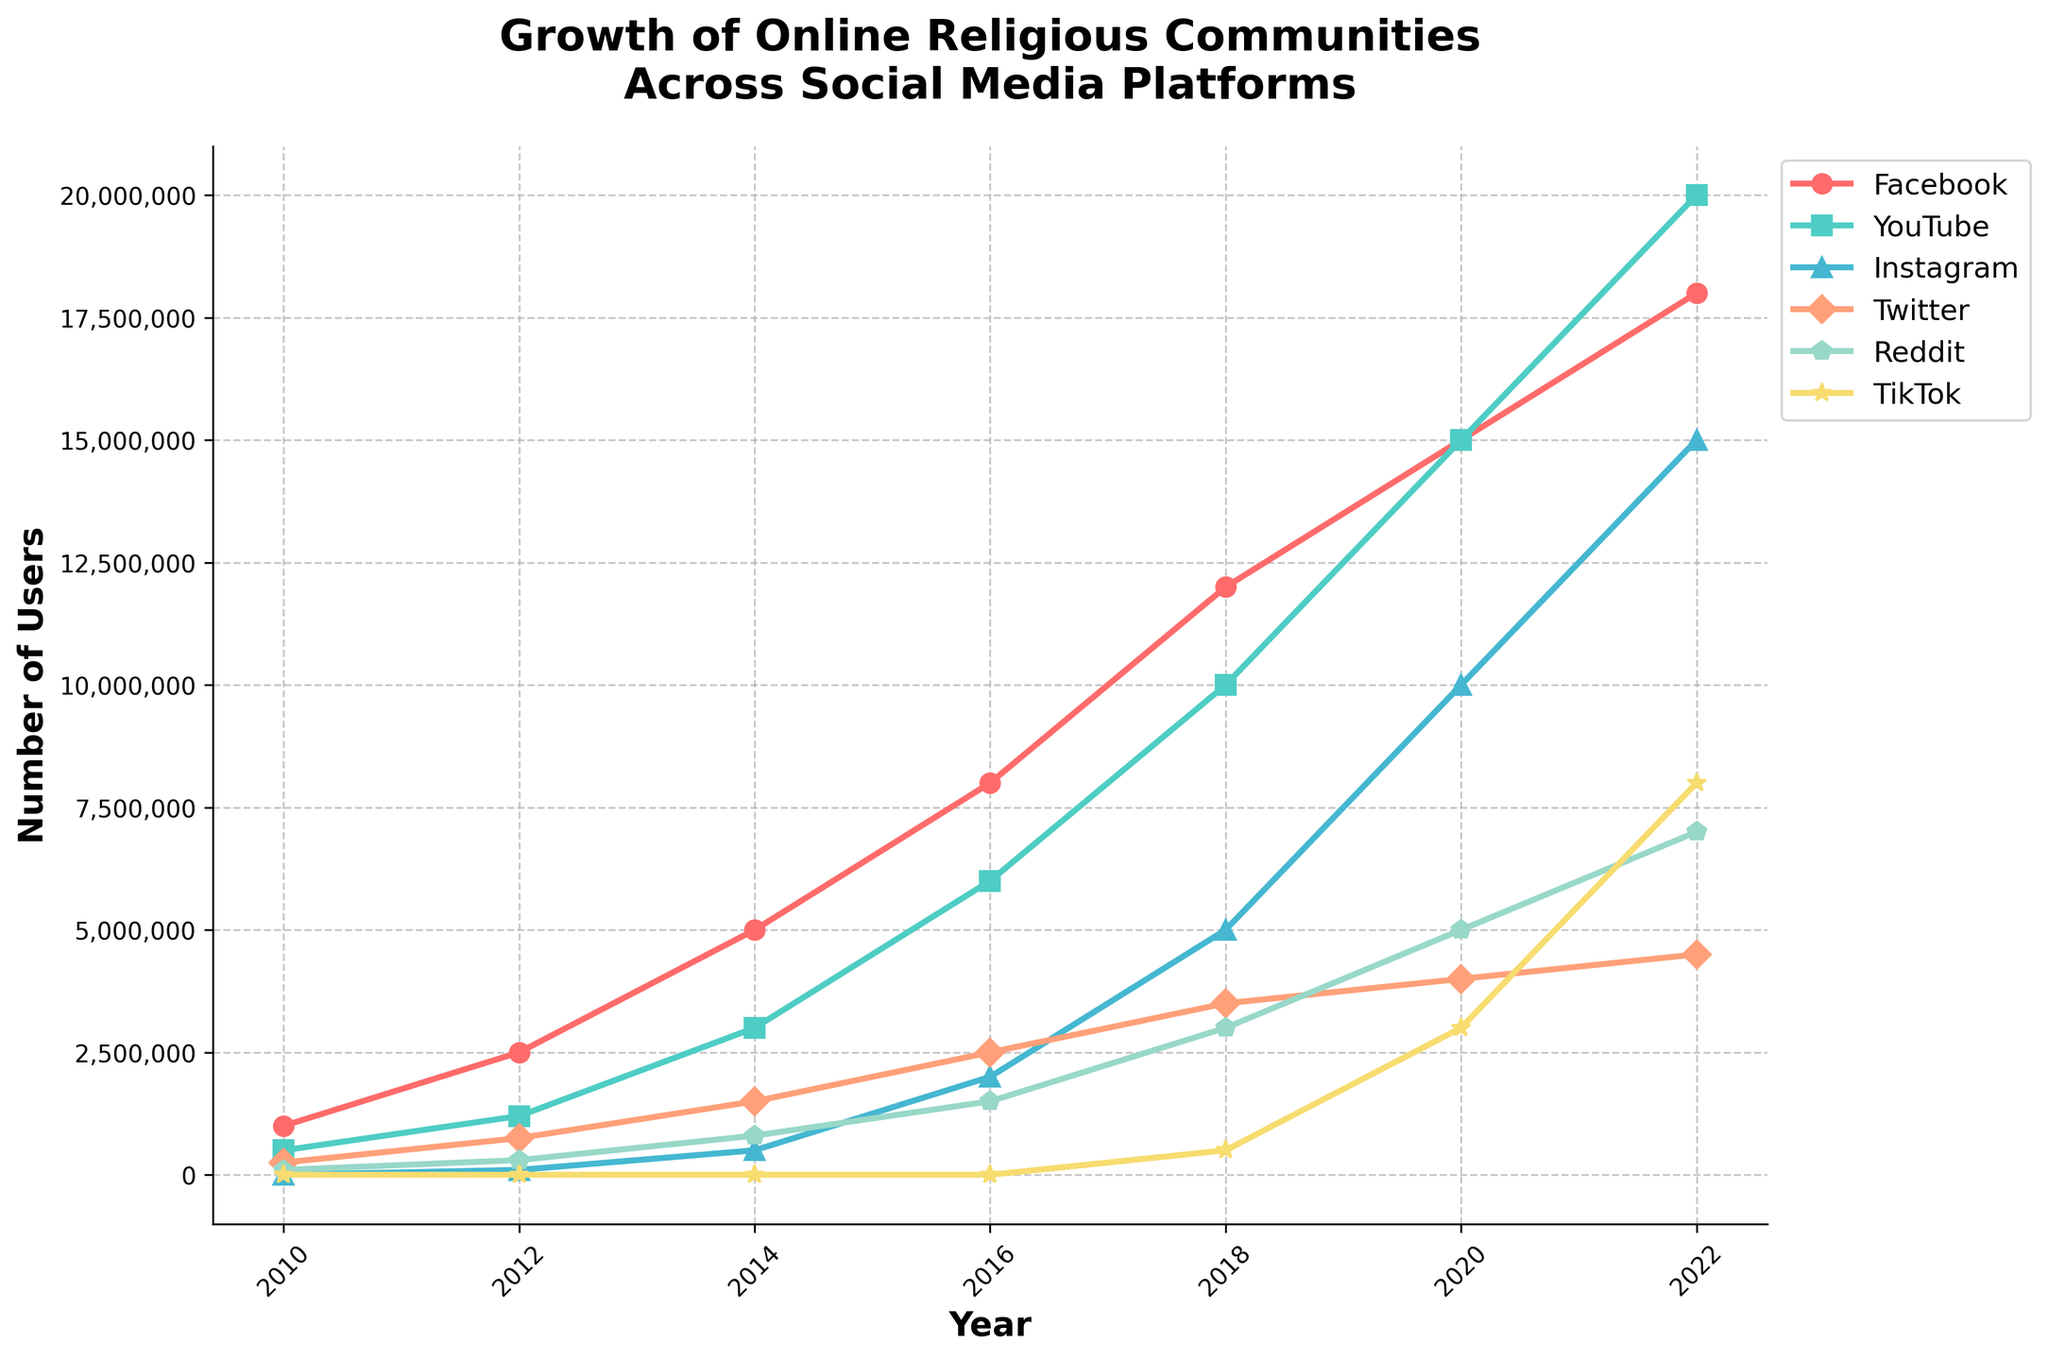How many more users did Facebook gain from 2010 to 2022? In 2010, Facebook had 1,000,000 users. By 2022, it had 18,000,000 users. The increase is 18,000,000 - 1,000,000 = 17,000,000.
Answer: 17,000,000 Which platform saw the most significant growth in users between 2016 and 2022? By looking at the height difference of the lines from 2016 to 2022, YouTube showed the largest increase, from 6,000,000 users in 2016 to 20,000,000 in 2022.
Answer: YouTube What is the difference in the number of users between Instagram and Twitter in 2022? In 2022, Instagram had 15,000,000 users, and Twitter had 4,500,000 users. The difference is 15,000,000 - 4,500,000 = 10,500,000.
Answer: 10,500,000 By how much did Reddit's user base grow from 2014 to 2022? In 2014, Reddit had 800,000 users. In 2022, it had 7,000,000 users. The growth is 7,000,000 - 800,000 = 6,200,000.
Answer: 6,200,000 Which platforms had no users in 2010? By inspecting the starting points of each line in 2010, Instagram and TikTok had 0 users in 2010.
Answer: Instagram, TikTok How did TikTok's growth from 2020 to 2022 compare to that of Facebook? TikTok grew from 3,000,000 users in 2020 to 8,000,000 in 2022, a 5,000,000 increase. Facebook grew from 15,000,000 to 18,000,000, a 3,000,000 increase. TikTok's growth was 5,000,000, which is larger than Facebook's 3,000,000.
Answer: TikTok's growth was larger What is the combined number of users across all platforms in 2018? Sum the users of all platforms in 2018: 12,000,000 (Facebook) + 10,000,000 (YouTube) + 5,000,000 (Instagram) + 3,500,000 (Twitter) + 3,000,000 (Reddit) + 500,000 (TikTok) = 34,000,000.
Answer: 34,000,000 Which platform had the smallest user base in 2020? By comparing the heights of the lines in 2020, TikTok had the smallest user base with 3,000,000 users.
Answer: TikTok Is there any year when YouTube had the same number of users as Facebook? If so, which year? Both YouTube and Facebook had 15,000,000 users in 2020.
Answer: 2020 